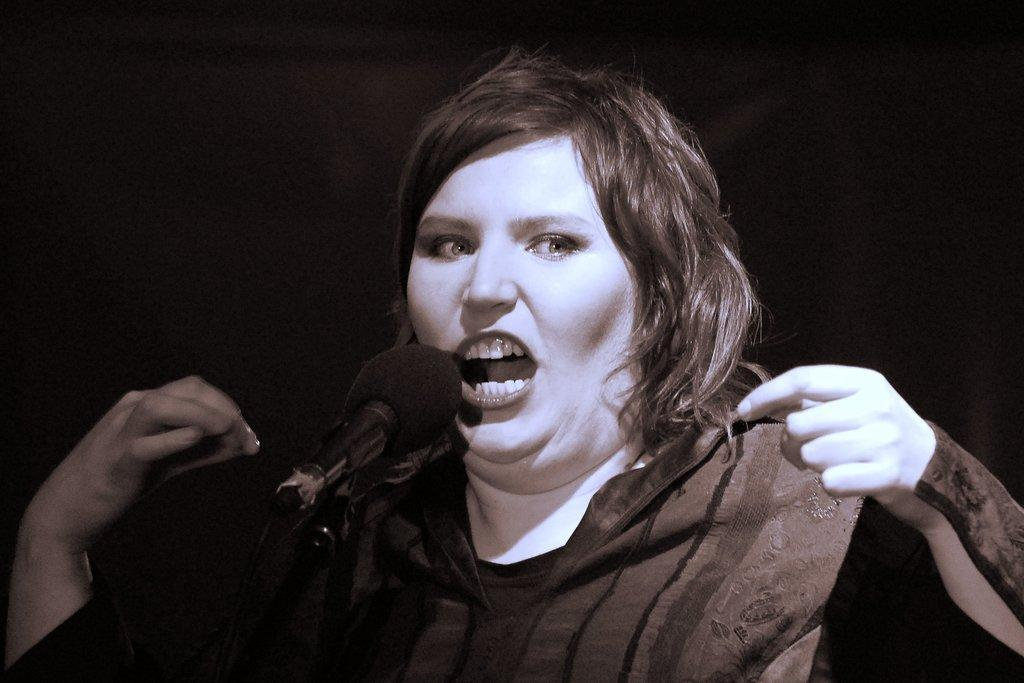What is the main subject of the image? There is a person in the image. What object is associated with the person in the image? There is a microphone in the image. What type of balloon can be seen floating in the background of the image? There is no balloon present in the image. What is the person using to crack open a nut in the image? There is no nut or cracking activity depicted in the image. 